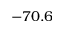<formula> <loc_0><loc_0><loc_500><loc_500>- 7 0 . 6</formula> 